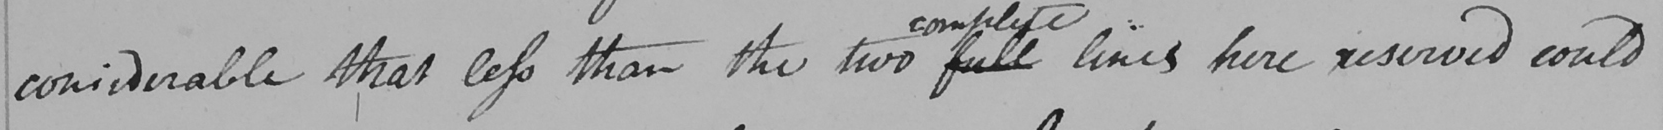What text is written in this handwritten line? considerable that less than the two full lines here reserved could 